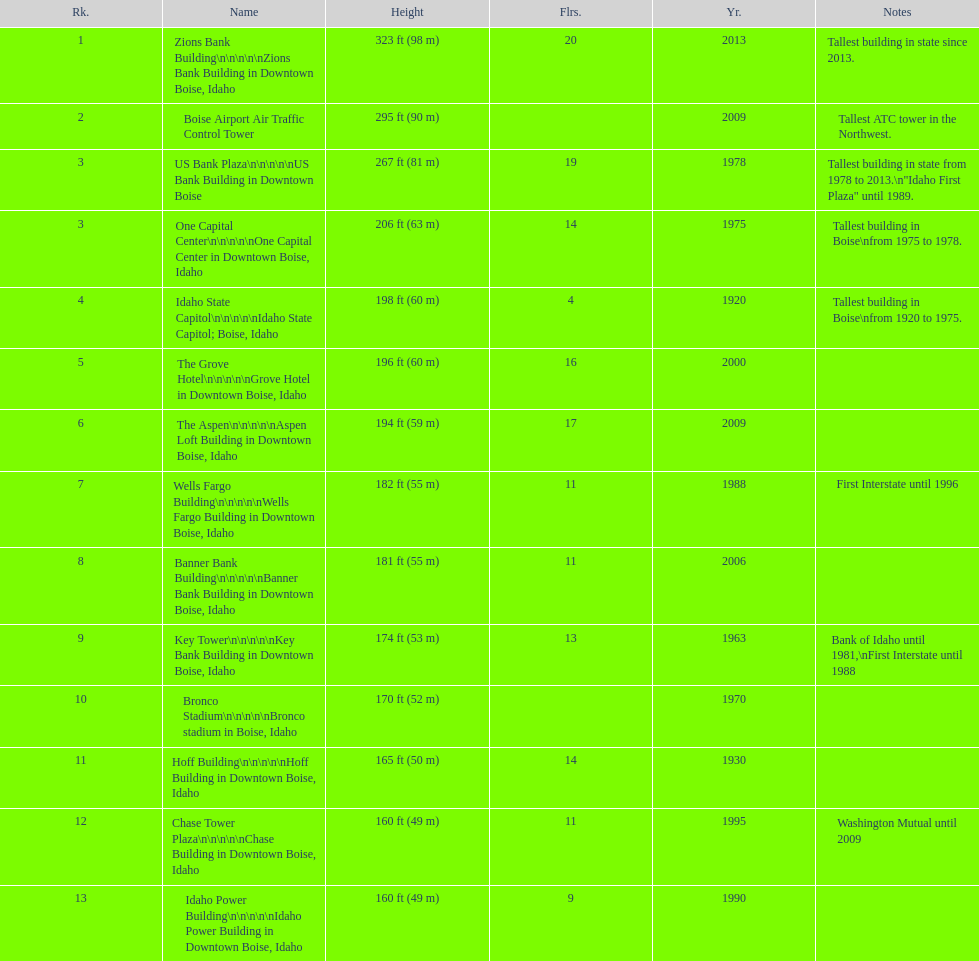What is the tallest building in bosie, idaho? Zions Bank Building Zions Bank Building in Downtown Boise, Idaho. 